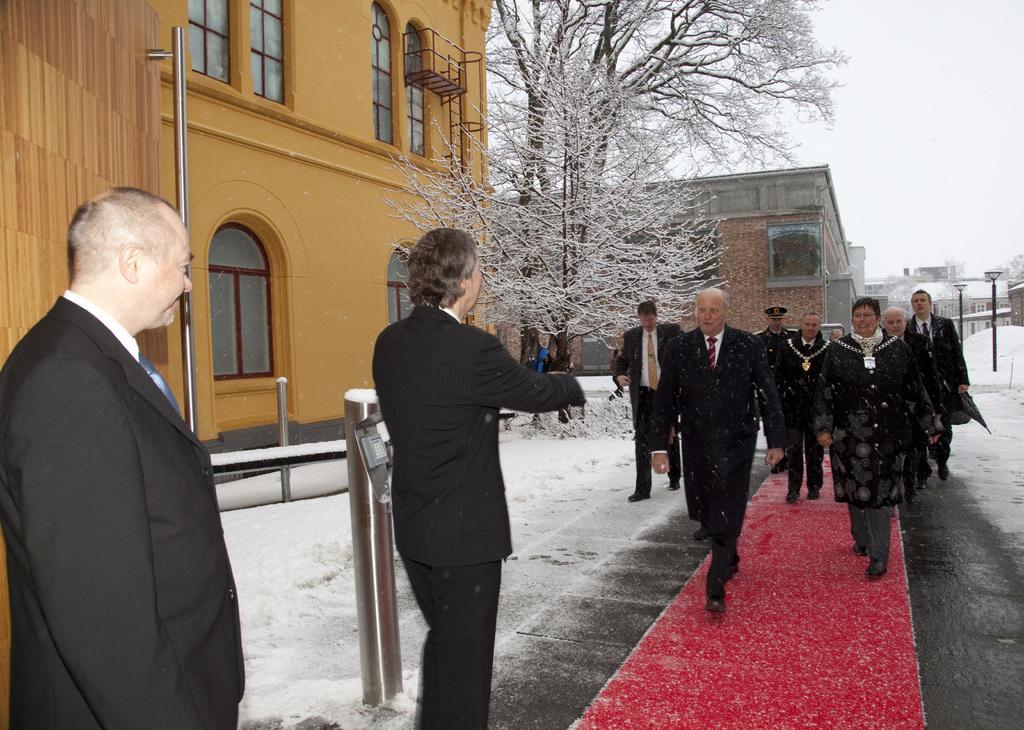Please provide a concise description of this image. In this image, we can see a group of people. Few are standing and walking. Here a person is smiling. Background we can see houses, building, door, handle, windows, trees, poles with lights, rods, snow and sky. On the right side of the image, we can see a red carpet. 